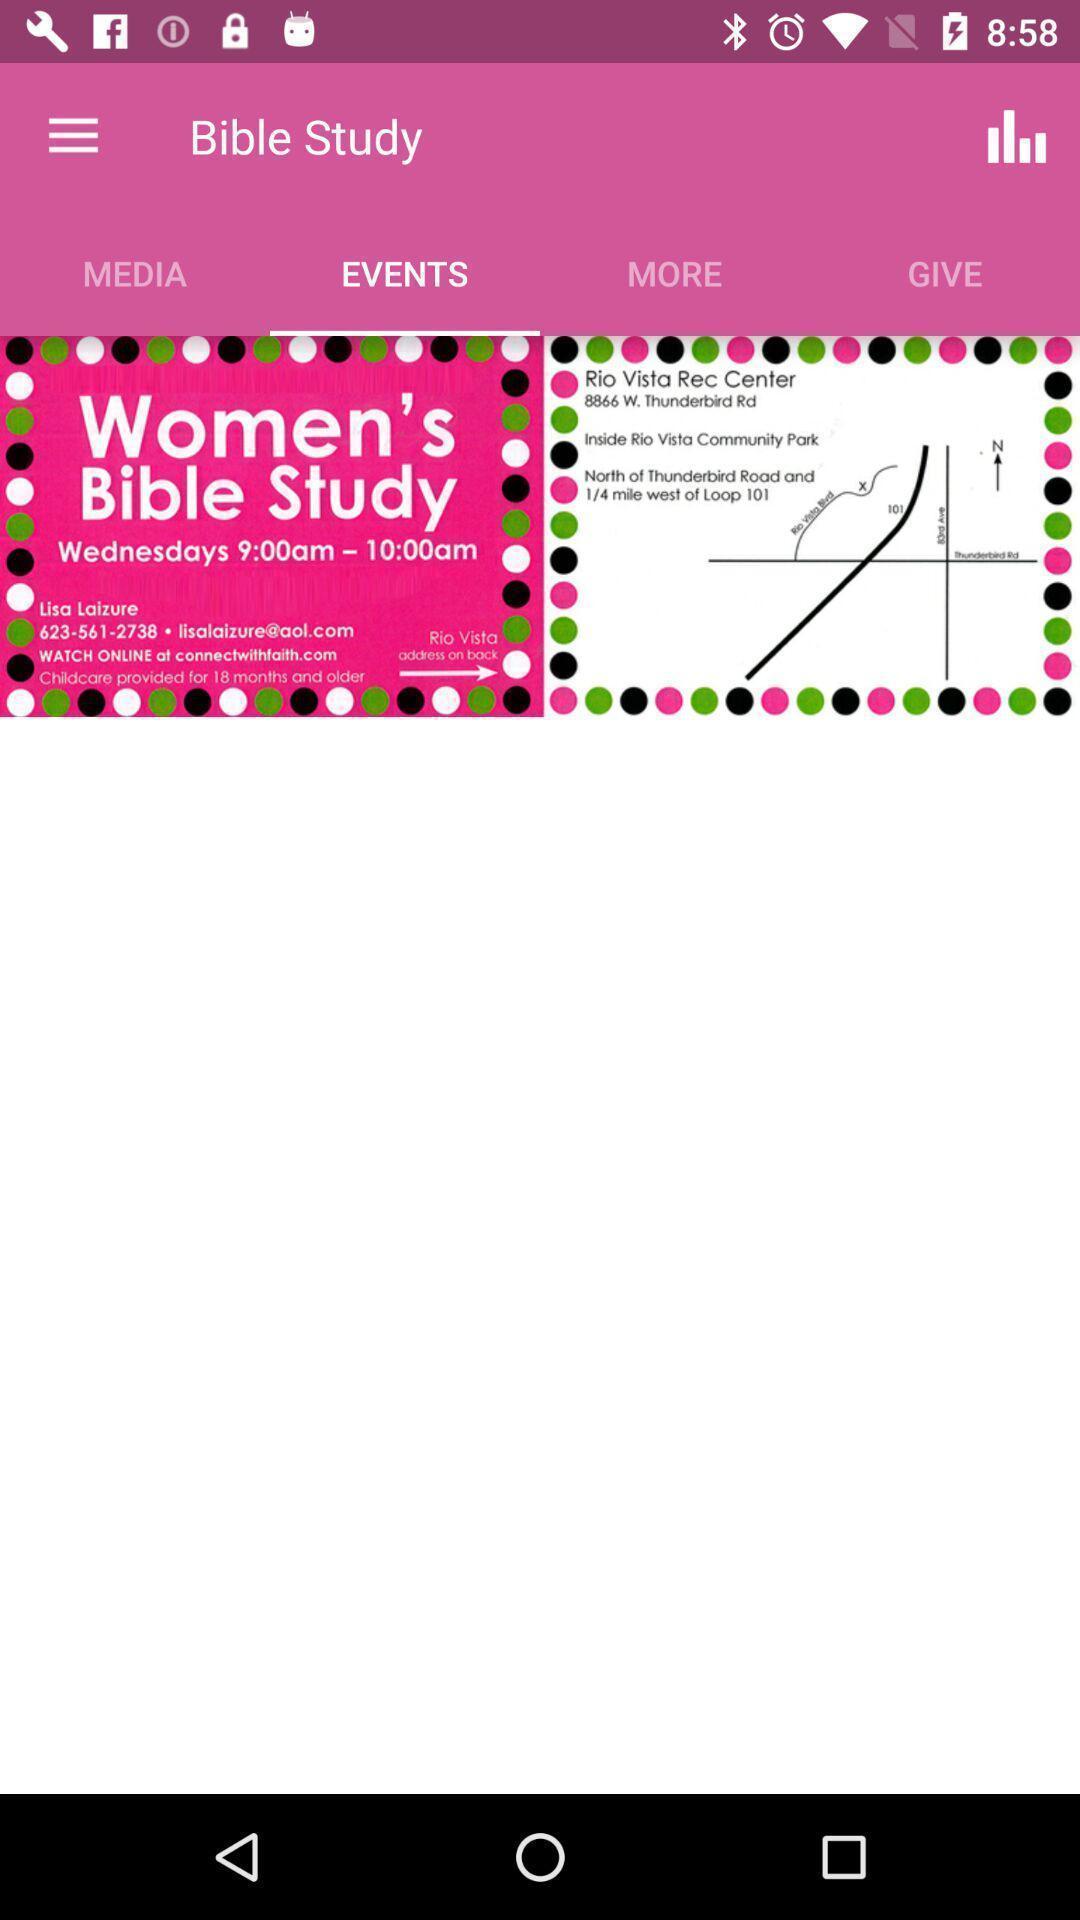Provide a description of this screenshot. Screen displaying the events page of a holy app. 